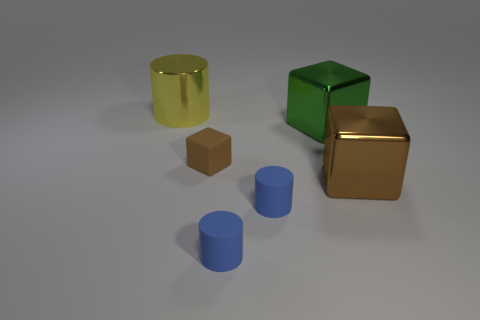Subtract all brown blocks. How many were subtracted if there are1brown blocks left? 1 Add 2 big yellow objects. How many objects exist? 8 Add 6 tiny cubes. How many tiny cubes are left? 7 Add 5 large metal objects. How many large metal objects exist? 8 Subtract 1 green cubes. How many objects are left? 5 Subtract all big shiny objects. Subtract all big green shiny objects. How many objects are left? 2 